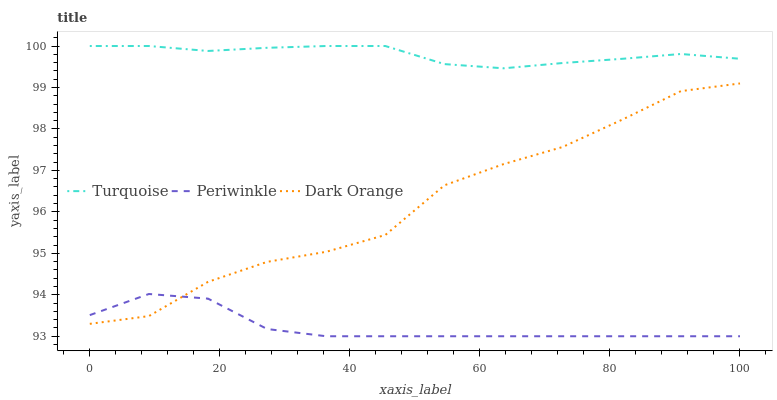Does Periwinkle have the minimum area under the curve?
Answer yes or no. Yes. Does Turquoise have the maximum area under the curve?
Answer yes or no. Yes. Does Turquoise have the minimum area under the curve?
Answer yes or no. No. Does Periwinkle have the maximum area under the curve?
Answer yes or no. No. Is Turquoise the smoothest?
Answer yes or no. Yes. Is Dark Orange the roughest?
Answer yes or no. Yes. Is Periwinkle the smoothest?
Answer yes or no. No. Is Periwinkle the roughest?
Answer yes or no. No. Does Periwinkle have the lowest value?
Answer yes or no. Yes. Does Turquoise have the lowest value?
Answer yes or no. No. Does Turquoise have the highest value?
Answer yes or no. Yes. Does Periwinkle have the highest value?
Answer yes or no. No. Is Periwinkle less than Turquoise?
Answer yes or no. Yes. Is Turquoise greater than Dark Orange?
Answer yes or no. Yes. Does Periwinkle intersect Dark Orange?
Answer yes or no. Yes. Is Periwinkle less than Dark Orange?
Answer yes or no. No. Is Periwinkle greater than Dark Orange?
Answer yes or no. No. Does Periwinkle intersect Turquoise?
Answer yes or no. No. 